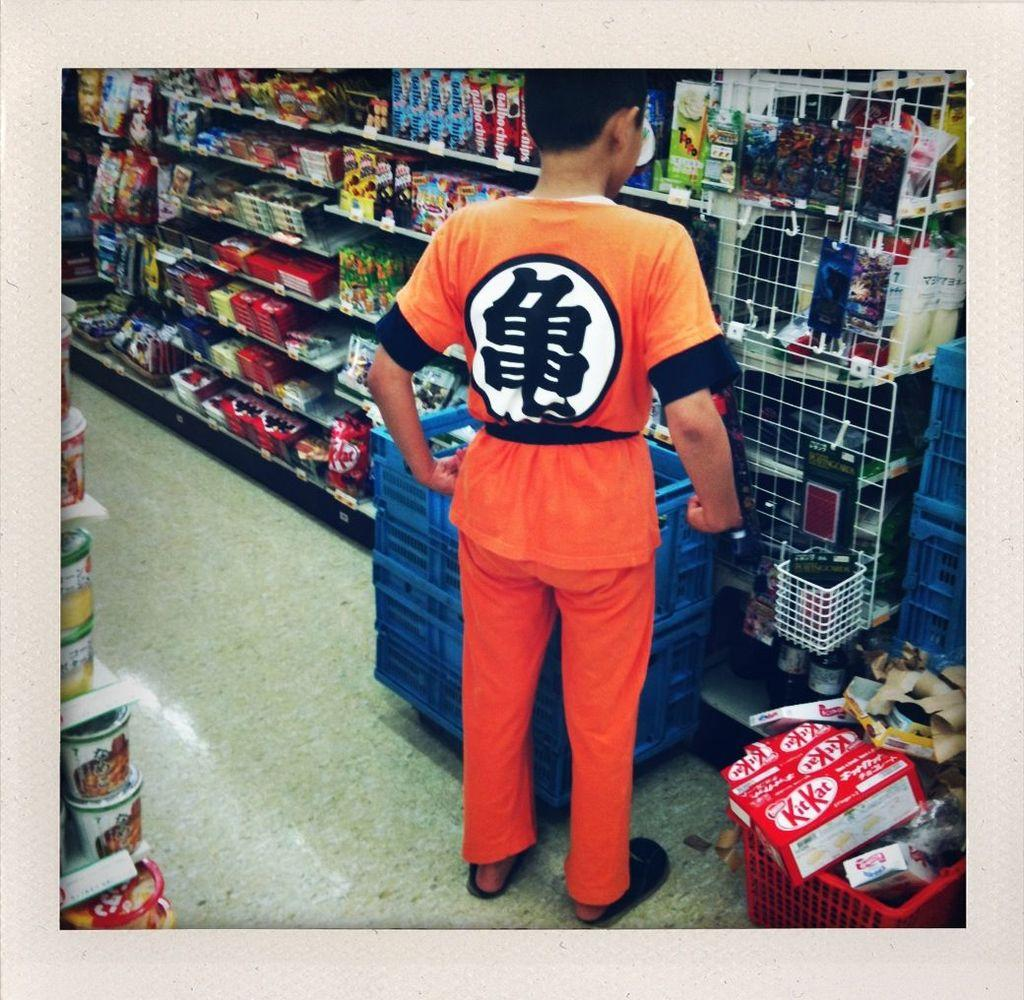<image>
Provide a brief description of the given image. A red shopping cart on a store floor with a box of KitKat in it 